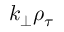<formula> <loc_0><loc_0><loc_500><loc_500>k _ { \perp } \rho _ { \tau }</formula> 